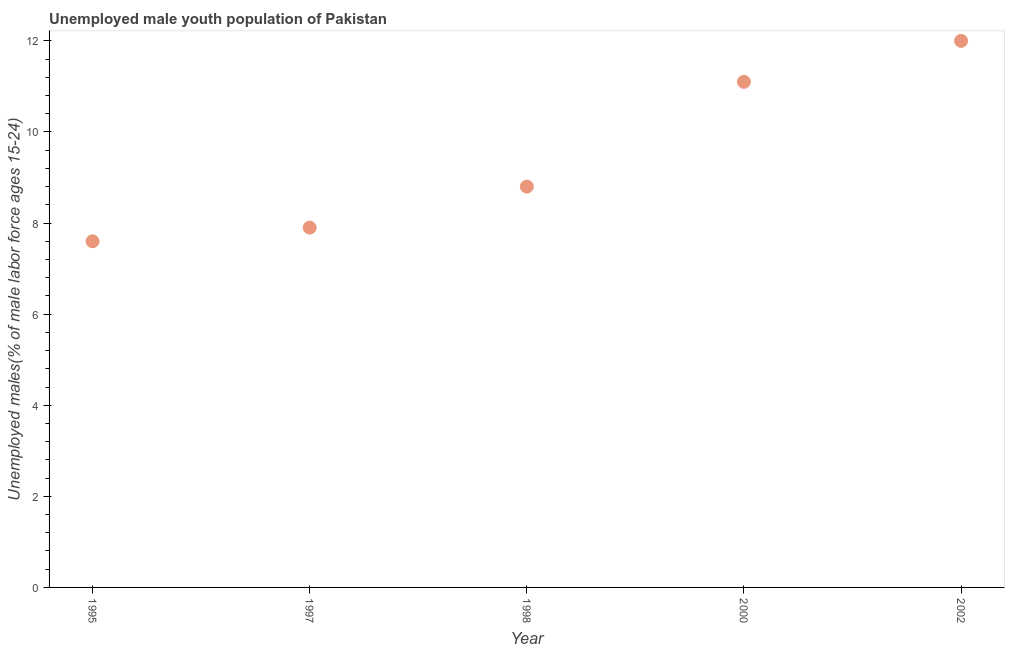What is the unemployed male youth in 1998?
Make the answer very short. 8.8. Across all years, what is the maximum unemployed male youth?
Provide a succinct answer. 12. Across all years, what is the minimum unemployed male youth?
Give a very brief answer. 7.6. In which year was the unemployed male youth minimum?
Your response must be concise. 1995. What is the sum of the unemployed male youth?
Keep it short and to the point. 47.4. What is the difference between the unemployed male youth in 1997 and 1998?
Provide a succinct answer. -0.9. What is the average unemployed male youth per year?
Your response must be concise. 9.48. What is the median unemployed male youth?
Give a very brief answer. 8.8. What is the ratio of the unemployed male youth in 1995 to that in 2002?
Make the answer very short. 0.63. Is the difference between the unemployed male youth in 1997 and 2002 greater than the difference between any two years?
Provide a short and direct response. No. What is the difference between the highest and the second highest unemployed male youth?
Your answer should be compact. 0.9. What is the difference between the highest and the lowest unemployed male youth?
Your response must be concise. 4.4. How many dotlines are there?
Give a very brief answer. 1. What is the difference between two consecutive major ticks on the Y-axis?
Your answer should be very brief. 2. What is the title of the graph?
Your answer should be very brief. Unemployed male youth population of Pakistan. What is the label or title of the Y-axis?
Provide a succinct answer. Unemployed males(% of male labor force ages 15-24). What is the Unemployed males(% of male labor force ages 15-24) in 1995?
Your response must be concise. 7.6. What is the Unemployed males(% of male labor force ages 15-24) in 1997?
Offer a terse response. 7.9. What is the Unemployed males(% of male labor force ages 15-24) in 1998?
Give a very brief answer. 8.8. What is the Unemployed males(% of male labor force ages 15-24) in 2000?
Ensure brevity in your answer.  11.1. What is the Unemployed males(% of male labor force ages 15-24) in 2002?
Offer a very short reply. 12. What is the difference between the Unemployed males(% of male labor force ages 15-24) in 1995 and 1997?
Provide a short and direct response. -0.3. What is the difference between the Unemployed males(% of male labor force ages 15-24) in 1995 and 2002?
Offer a very short reply. -4.4. What is the difference between the Unemployed males(% of male labor force ages 15-24) in 1997 and 2000?
Your answer should be compact. -3.2. What is the difference between the Unemployed males(% of male labor force ages 15-24) in 1997 and 2002?
Offer a very short reply. -4.1. What is the difference between the Unemployed males(% of male labor force ages 15-24) in 1998 and 2000?
Offer a terse response. -2.3. What is the ratio of the Unemployed males(% of male labor force ages 15-24) in 1995 to that in 1997?
Provide a succinct answer. 0.96. What is the ratio of the Unemployed males(% of male labor force ages 15-24) in 1995 to that in 1998?
Offer a terse response. 0.86. What is the ratio of the Unemployed males(% of male labor force ages 15-24) in 1995 to that in 2000?
Offer a very short reply. 0.69. What is the ratio of the Unemployed males(% of male labor force ages 15-24) in 1995 to that in 2002?
Your answer should be very brief. 0.63. What is the ratio of the Unemployed males(% of male labor force ages 15-24) in 1997 to that in 1998?
Provide a short and direct response. 0.9. What is the ratio of the Unemployed males(% of male labor force ages 15-24) in 1997 to that in 2000?
Offer a very short reply. 0.71. What is the ratio of the Unemployed males(% of male labor force ages 15-24) in 1997 to that in 2002?
Give a very brief answer. 0.66. What is the ratio of the Unemployed males(% of male labor force ages 15-24) in 1998 to that in 2000?
Give a very brief answer. 0.79. What is the ratio of the Unemployed males(% of male labor force ages 15-24) in 1998 to that in 2002?
Make the answer very short. 0.73. What is the ratio of the Unemployed males(% of male labor force ages 15-24) in 2000 to that in 2002?
Keep it short and to the point. 0.93. 